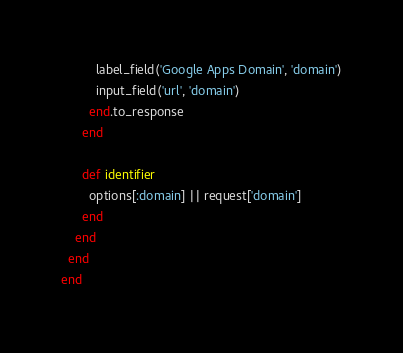<code> <loc_0><loc_0><loc_500><loc_500><_Ruby_>          label_field('Google Apps Domain', 'domain')
          input_field('url', 'domain')
        end.to_response
      end
      
      def identifier
        options[:domain] || request['domain']
      end
    end
  end
end
</code> 